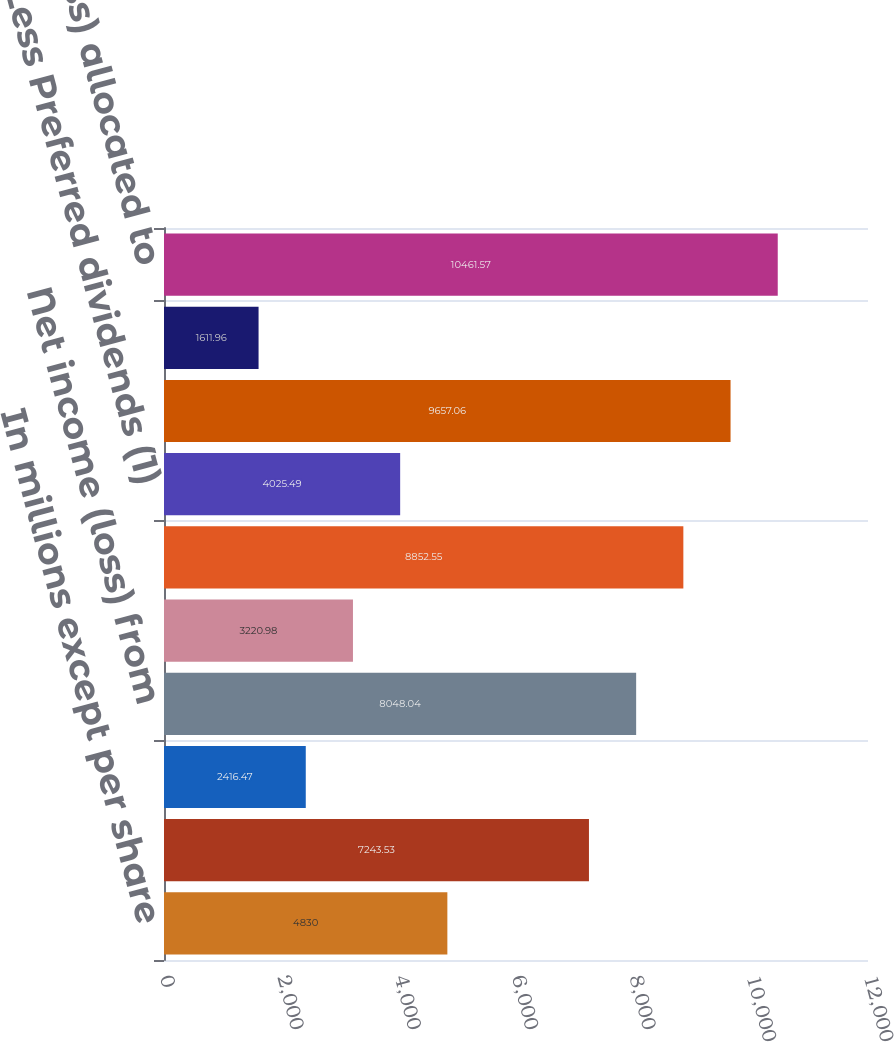Convert chart. <chart><loc_0><loc_0><loc_500><loc_500><bar_chart><fcel>In millions except per share<fcel>Income (loss) from continuing<fcel>Less Noncontrolling interests<fcel>Net income (loss) from<fcel>Income (loss) from<fcel>Citigroup's net income (loss)<fcel>Less Preferred dividends (1)<fcel>Net income (loss) available to<fcel>Less Dividends and<fcel>Net income (loss) allocated to<nl><fcel>4830<fcel>7243.53<fcel>2416.47<fcel>8048.04<fcel>3220.98<fcel>8852.55<fcel>4025.49<fcel>9657.06<fcel>1611.96<fcel>10461.6<nl></chart> 